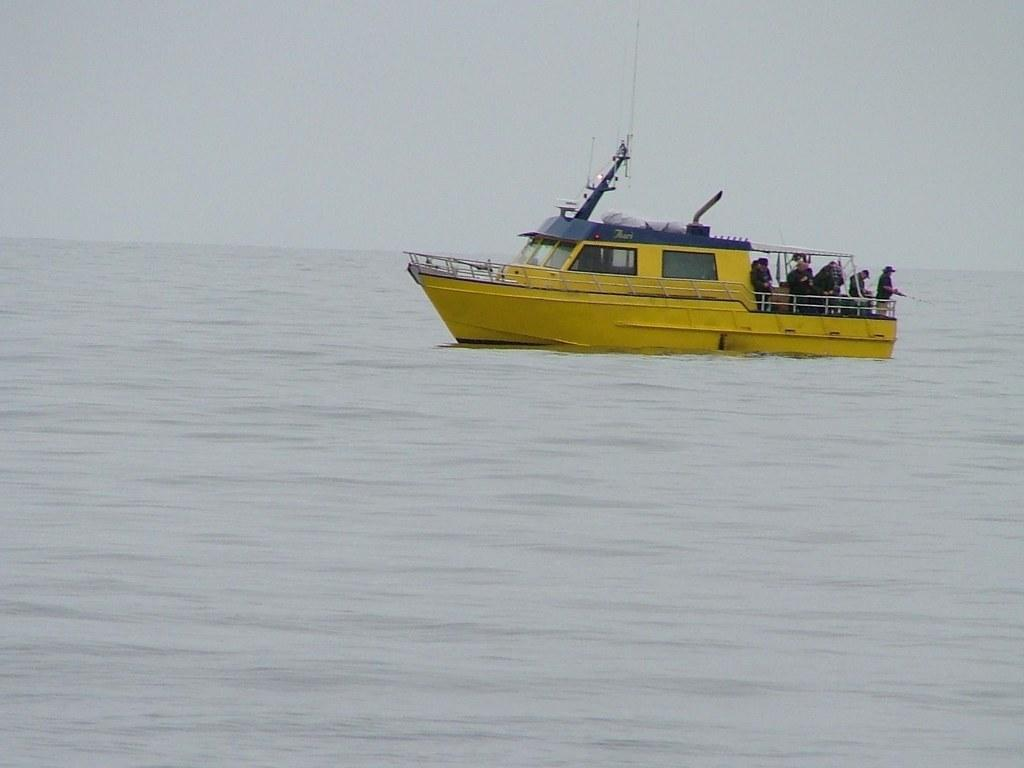What is the main subject of the image? The main subject of the image is a ship. Where is the ship located in the image? The ship is on the surface of water. What can be seen in the background of the image? There is sky visible in the background of the image. Are there any people present in the image? Yes, there are people on the ship. How many robins can be seen flying around the ship in the image? There are no robins present in the image; it features a ship on the water with people on board. 